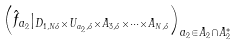Convert formula to latex. <formula><loc_0><loc_0><loc_500><loc_500>\left ( \hat { f } _ { a _ { 2 } } | _ { D _ { 1 , N \delta } \times U _ { a _ { 2 } , \delta } \times A _ { 3 , \delta } \times \cdots \times A _ { N , \delta } } \right ) _ { a _ { 2 } \in A _ { 2 } \cap A ^ { \ast } _ { 2 } }</formula> 